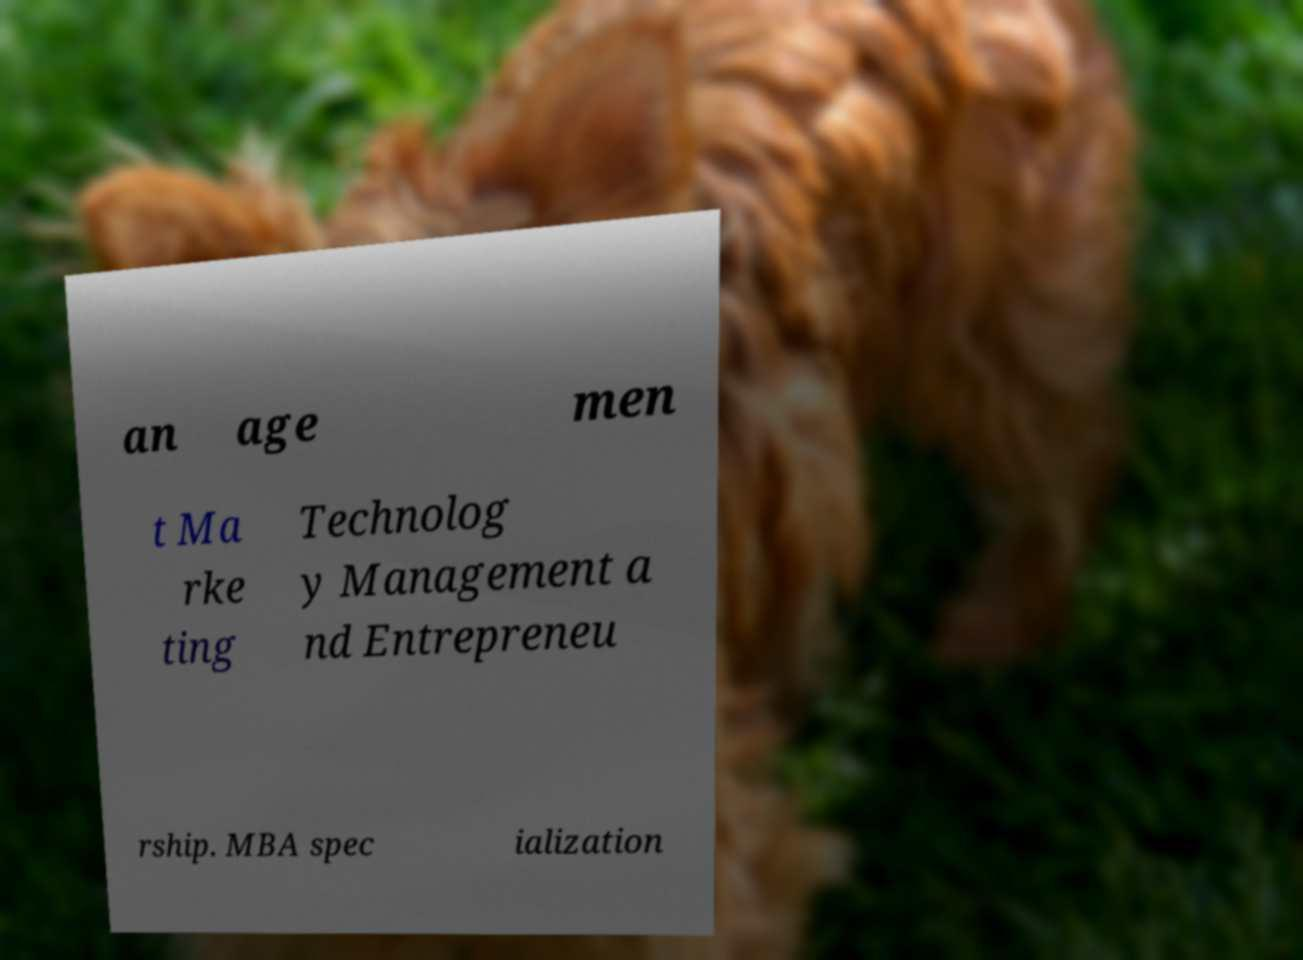Please identify and transcribe the text found in this image. an age men t Ma rke ting Technolog y Management a nd Entrepreneu rship. MBA spec ialization 